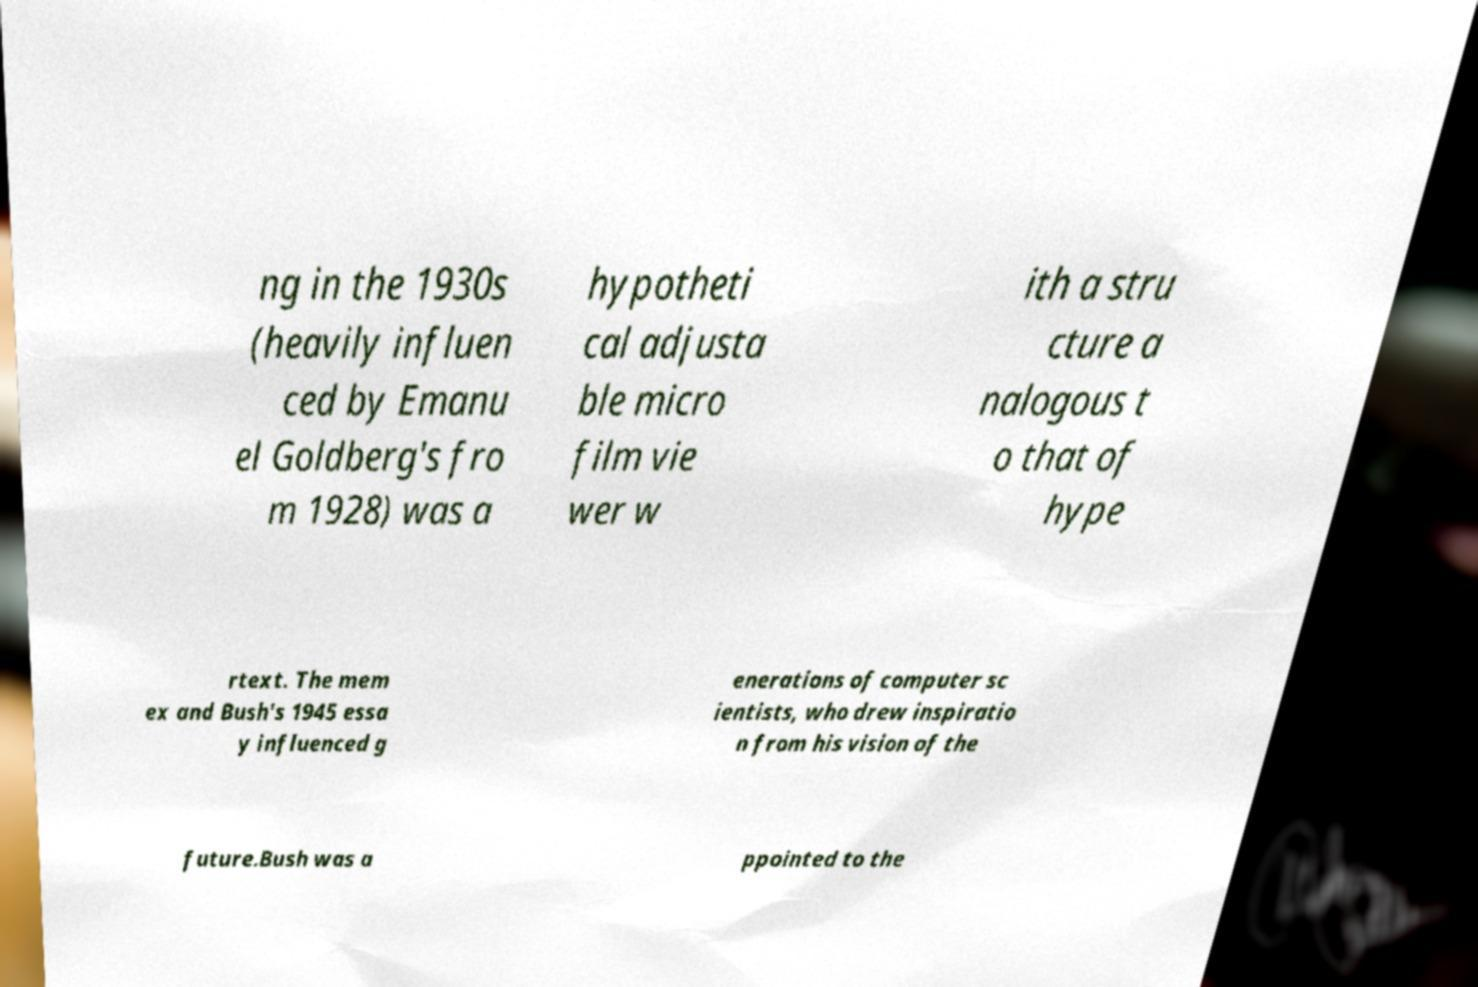What messages or text are displayed in this image? I need them in a readable, typed format. ng in the 1930s (heavily influen ced by Emanu el Goldberg's fro m 1928) was a hypotheti cal adjusta ble micro film vie wer w ith a stru cture a nalogous t o that of hype rtext. The mem ex and Bush's 1945 essa y influenced g enerations of computer sc ientists, who drew inspiratio n from his vision of the future.Bush was a ppointed to the 